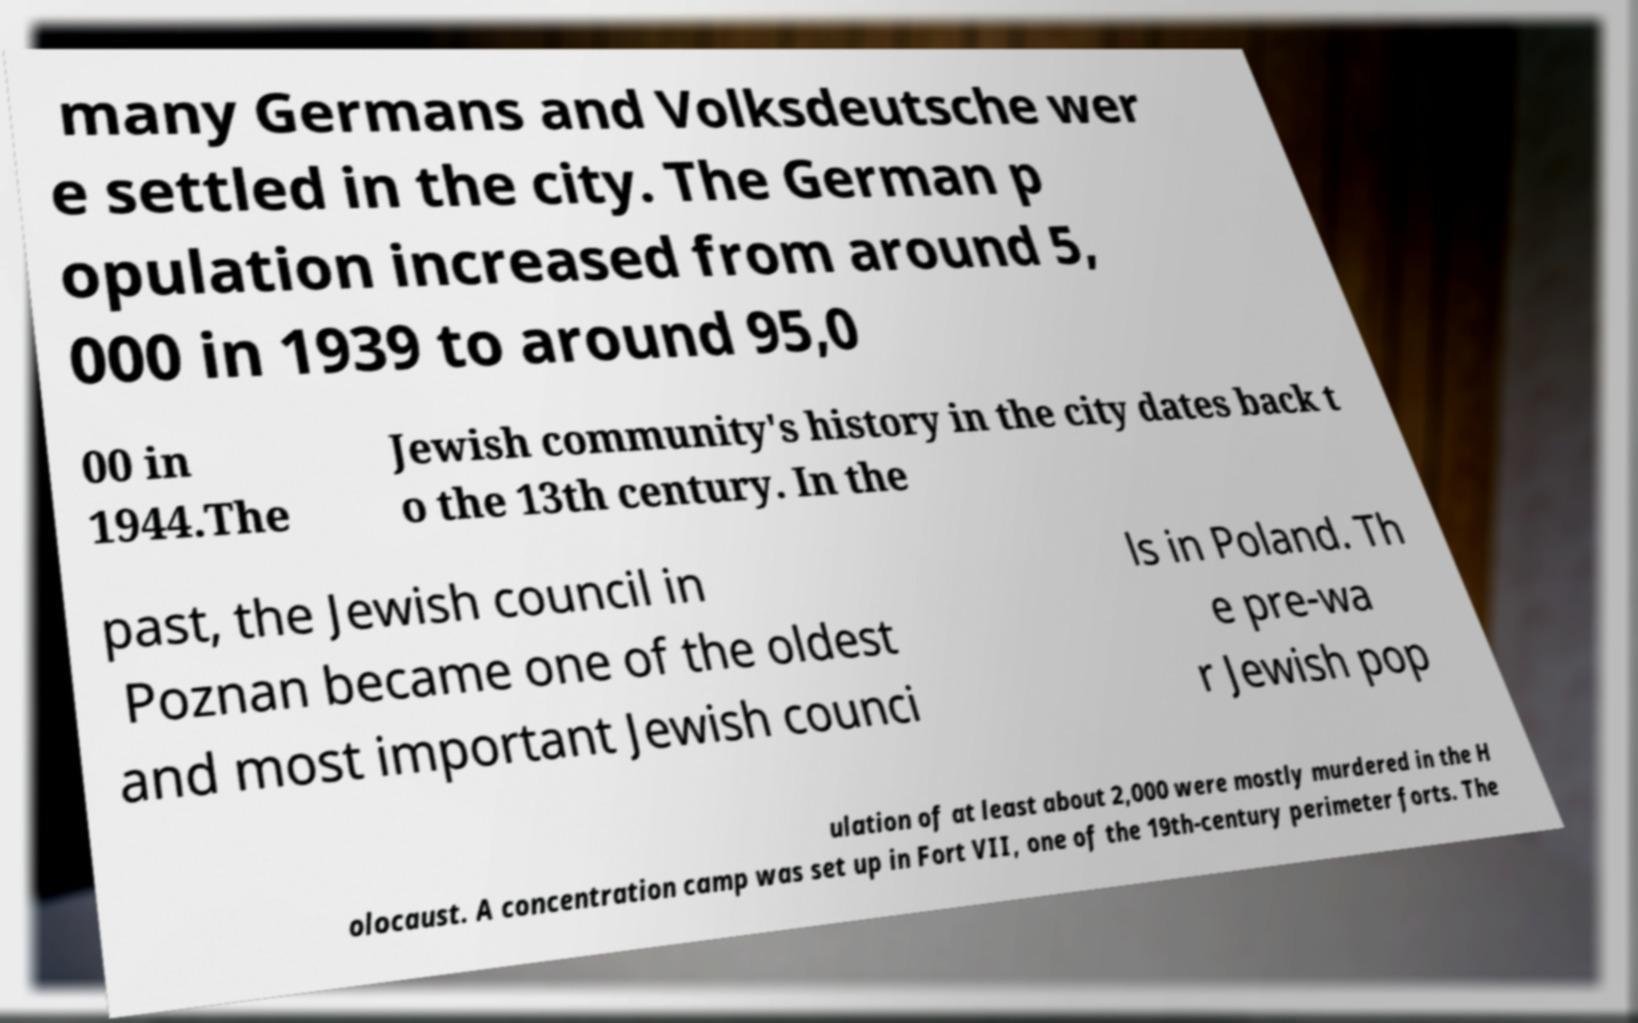There's text embedded in this image that I need extracted. Can you transcribe it verbatim? many Germans and Volksdeutsche wer e settled in the city. The German p opulation increased from around 5, 000 in 1939 to around 95,0 00 in 1944.The Jewish community's history in the city dates back t o the 13th century. In the past, the Jewish council in Poznan became one of the oldest and most important Jewish counci ls in Poland. Th e pre-wa r Jewish pop ulation of at least about 2,000 were mostly murdered in the H olocaust. A concentration camp was set up in Fort VII, one of the 19th-century perimeter forts. The 